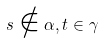<formula> <loc_0><loc_0><loc_500><loc_500>s \notin \alpha , t \in \gamma</formula> 